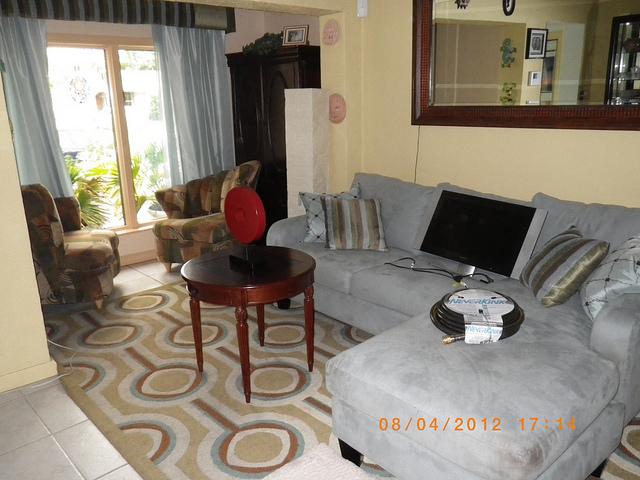How many pillows on the couch?
Concise answer only. 4. Where is the mirror?
Give a very brief answer. Wall. Is the room neatly maintained?
Answer briefly. Yes. 